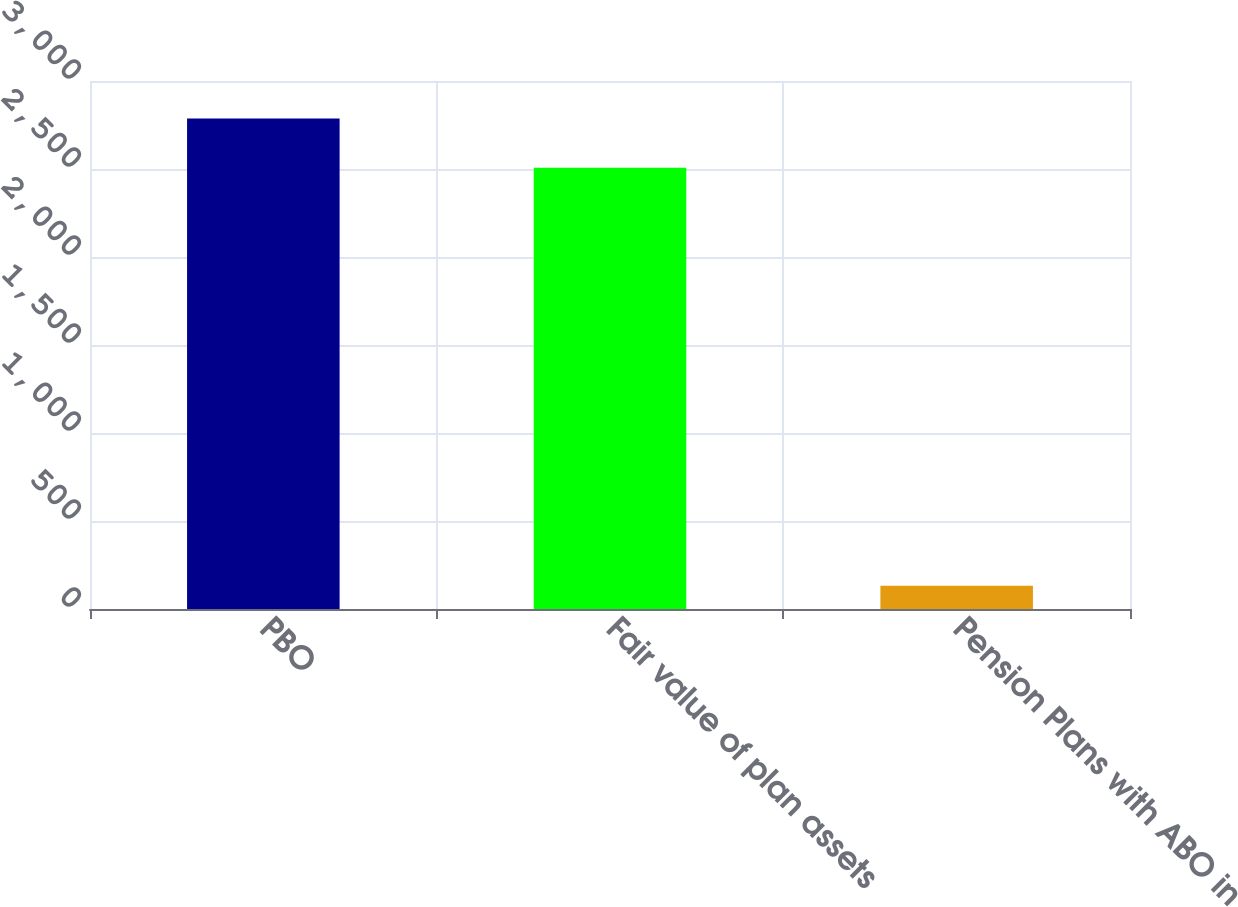<chart> <loc_0><loc_0><loc_500><loc_500><bar_chart><fcel>PBO<fcel>Fair value of plan assets<fcel>Pension Plans with ABO in<nl><fcel>2786.6<fcel>2507.3<fcel>131.4<nl></chart> 